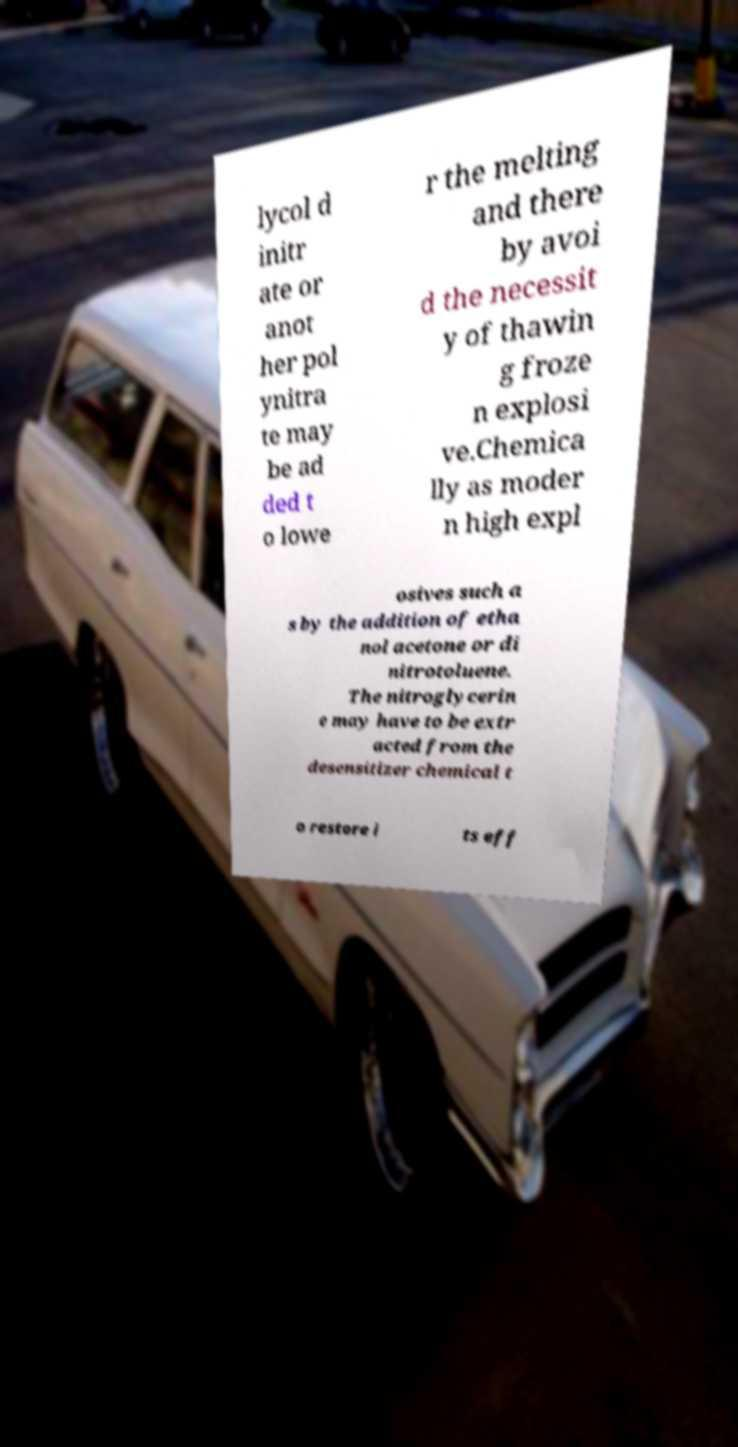I need the written content from this picture converted into text. Can you do that? lycol d initr ate or anot her pol ynitra te may be ad ded t o lowe r the melting and there by avoi d the necessit y of thawin g froze n explosi ve.Chemica lly as moder n high expl osives such a s by the addition of etha nol acetone or di nitrotoluene. The nitroglycerin e may have to be extr acted from the desensitizer chemical t o restore i ts eff 